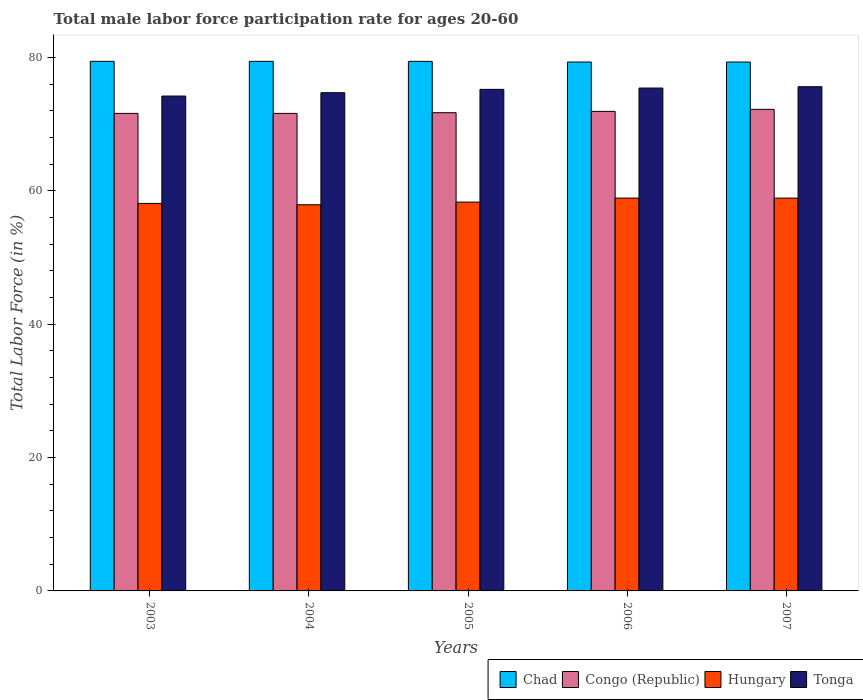How many different coloured bars are there?
Your answer should be very brief. 4. How many groups of bars are there?
Ensure brevity in your answer.  5. Are the number of bars per tick equal to the number of legend labels?
Provide a succinct answer. Yes. How many bars are there on the 4th tick from the left?
Offer a very short reply. 4. How many bars are there on the 3rd tick from the right?
Your answer should be very brief. 4. What is the label of the 5th group of bars from the left?
Offer a terse response. 2007. What is the male labor force participation rate in Hungary in 2004?
Your response must be concise. 57.9. Across all years, what is the maximum male labor force participation rate in Tonga?
Make the answer very short. 75.6. Across all years, what is the minimum male labor force participation rate in Tonga?
Offer a very short reply. 74.2. In which year was the male labor force participation rate in Congo (Republic) maximum?
Your answer should be compact. 2007. In which year was the male labor force participation rate in Chad minimum?
Your answer should be compact. 2006. What is the total male labor force participation rate in Congo (Republic) in the graph?
Offer a very short reply. 359. What is the difference between the male labor force participation rate in Congo (Republic) in 2003 and that in 2007?
Give a very brief answer. -0.6. What is the difference between the male labor force participation rate in Hungary in 2003 and the male labor force participation rate in Chad in 2004?
Your answer should be compact. -21.3. What is the average male labor force participation rate in Congo (Republic) per year?
Make the answer very short. 71.8. In the year 2004, what is the difference between the male labor force participation rate in Chad and male labor force participation rate in Tonga?
Your answer should be very brief. 4.7. What is the ratio of the male labor force participation rate in Tonga in 2005 to that in 2006?
Your response must be concise. 1. Is the difference between the male labor force participation rate in Chad in 2003 and 2004 greater than the difference between the male labor force participation rate in Tonga in 2003 and 2004?
Offer a very short reply. Yes. What is the difference between the highest and the second highest male labor force participation rate in Congo (Republic)?
Provide a succinct answer. 0.3. What is the difference between the highest and the lowest male labor force participation rate in Congo (Republic)?
Provide a succinct answer. 0.6. In how many years, is the male labor force participation rate in Tonga greater than the average male labor force participation rate in Tonga taken over all years?
Your answer should be very brief. 3. Is it the case that in every year, the sum of the male labor force participation rate in Tonga and male labor force participation rate in Congo (Republic) is greater than the sum of male labor force participation rate in Hungary and male labor force participation rate in Chad?
Provide a short and direct response. No. What does the 2nd bar from the left in 2004 represents?
Give a very brief answer. Congo (Republic). What does the 2nd bar from the right in 2003 represents?
Offer a terse response. Hungary. How many years are there in the graph?
Give a very brief answer. 5. How many legend labels are there?
Keep it short and to the point. 4. What is the title of the graph?
Your answer should be compact. Total male labor force participation rate for ages 20-60. What is the label or title of the X-axis?
Your response must be concise. Years. What is the label or title of the Y-axis?
Keep it short and to the point. Total Labor Force (in %). What is the Total Labor Force (in %) in Chad in 2003?
Keep it short and to the point. 79.4. What is the Total Labor Force (in %) in Congo (Republic) in 2003?
Offer a terse response. 71.6. What is the Total Labor Force (in %) of Hungary in 2003?
Keep it short and to the point. 58.1. What is the Total Labor Force (in %) of Tonga in 2003?
Provide a succinct answer. 74.2. What is the Total Labor Force (in %) in Chad in 2004?
Make the answer very short. 79.4. What is the Total Labor Force (in %) of Congo (Republic) in 2004?
Your answer should be very brief. 71.6. What is the Total Labor Force (in %) of Hungary in 2004?
Offer a very short reply. 57.9. What is the Total Labor Force (in %) of Tonga in 2004?
Provide a short and direct response. 74.7. What is the Total Labor Force (in %) of Chad in 2005?
Provide a succinct answer. 79.4. What is the Total Labor Force (in %) of Congo (Republic) in 2005?
Offer a very short reply. 71.7. What is the Total Labor Force (in %) in Hungary in 2005?
Provide a short and direct response. 58.3. What is the Total Labor Force (in %) of Tonga in 2005?
Offer a terse response. 75.2. What is the Total Labor Force (in %) in Chad in 2006?
Make the answer very short. 79.3. What is the Total Labor Force (in %) in Congo (Republic) in 2006?
Offer a very short reply. 71.9. What is the Total Labor Force (in %) of Hungary in 2006?
Provide a succinct answer. 58.9. What is the Total Labor Force (in %) of Tonga in 2006?
Your response must be concise. 75.4. What is the Total Labor Force (in %) of Chad in 2007?
Provide a succinct answer. 79.3. What is the Total Labor Force (in %) in Congo (Republic) in 2007?
Keep it short and to the point. 72.2. What is the Total Labor Force (in %) of Hungary in 2007?
Make the answer very short. 58.9. What is the Total Labor Force (in %) in Tonga in 2007?
Provide a succinct answer. 75.6. Across all years, what is the maximum Total Labor Force (in %) in Chad?
Your answer should be compact. 79.4. Across all years, what is the maximum Total Labor Force (in %) in Congo (Republic)?
Your response must be concise. 72.2. Across all years, what is the maximum Total Labor Force (in %) in Hungary?
Offer a very short reply. 58.9. Across all years, what is the maximum Total Labor Force (in %) of Tonga?
Your response must be concise. 75.6. Across all years, what is the minimum Total Labor Force (in %) of Chad?
Provide a succinct answer. 79.3. Across all years, what is the minimum Total Labor Force (in %) of Congo (Republic)?
Your answer should be very brief. 71.6. Across all years, what is the minimum Total Labor Force (in %) of Hungary?
Your response must be concise. 57.9. Across all years, what is the minimum Total Labor Force (in %) of Tonga?
Your response must be concise. 74.2. What is the total Total Labor Force (in %) of Chad in the graph?
Offer a terse response. 396.8. What is the total Total Labor Force (in %) in Congo (Republic) in the graph?
Provide a short and direct response. 359. What is the total Total Labor Force (in %) of Hungary in the graph?
Provide a succinct answer. 292.1. What is the total Total Labor Force (in %) of Tonga in the graph?
Keep it short and to the point. 375.1. What is the difference between the Total Labor Force (in %) of Chad in 2003 and that in 2004?
Your answer should be very brief. 0. What is the difference between the Total Labor Force (in %) in Hungary in 2003 and that in 2006?
Provide a succinct answer. -0.8. What is the difference between the Total Labor Force (in %) in Tonga in 2003 and that in 2007?
Keep it short and to the point. -1.4. What is the difference between the Total Labor Force (in %) of Congo (Republic) in 2004 and that in 2005?
Provide a short and direct response. -0.1. What is the difference between the Total Labor Force (in %) in Hungary in 2004 and that in 2005?
Ensure brevity in your answer.  -0.4. What is the difference between the Total Labor Force (in %) of Tonga in 2004 and that in 2005?
Keep it short and to the point. -0.5. What is the difference between the Total Labor Force (in %) of Congo (Republic) in 2004 and that in 2006?
Provide a succinct answer. -0.3. What is the difference between the Total Labor Force (in %) of Tonga in 2004 and that in 2006?
Your answer should be compact. -0.7. What is the difference between the Total Labor Force (in %) of Chad in 2004 and that in 2007?
Provide a short and direct response. 0.1. What is the difference between the Total Labor Force (in %) in Hungary in 2004 and that in 2007?
Offer a terse response. -1. What is the difference between the Total Labor Force (in %) in Congo (Republic) in 2005 and that in 2006?
Your answer should be compact. -0.2. What is the difference between the Total Labor Force (in %) of Tonga in 2005 and that in 2006?
Provide a succinct answer. -0.2. What is the difference between the Total Labor Force (in %) of Chad in 2005 and that in 2007?
Offer a very short reply. 0.1. What is the difference between the Total Labor Force (in %) of Congo (Republic) in 2005 and that in 2007?
Keep it short and to the point. -0.5. What is the difference between the Total Labor Force (in %) of Hungary in 2006 and that in 2007?
Offer a very short reply. 0. What is the difference between the Total Labor Force (in %) of Chad in 2003 and the Total Labor Force (in %) of Congo (Republic) in 2004?
Ensure brevity in your answer.  7.8. What is the difference between the Total Labor Force (in %) of Congo (Republic) in 2003 and the Total Labor Force (in %) of Tonga in 2004?
Your answer should be compact. -3.1. What is the difference between the Total Labor Force (in %) in Hungary in 2003 and the Total Labor Force (in %) in Tonga in 2004?
Keep it short and to the point. -16.6. What is the difference between the Total Labor Force (in %) of Chad in 2003 and the Total Labor Force (in %) of Congo (Republic) in 2005?
Offer a very short reply. 7.7. What is the difference between the Total Labor Force (in %) in Chad in 2003 and the Total Labor Force (in %) in Hungary in 2005?
Make the answer very short. 21.1. What is the difference between the Total Labor Force (in %) of Chad in 2003 and the Total Labor Force (in %) of Tonga in 2005?
Your answer should be very brief. 4.2. What is the difference between the Total Labor Force (in %) of Congo (Republic) in 2003 and the Total Labor Force (in %) of Hungary in 2005?
Keep it short and to the point. 13.3. What is the difference between the Total Labor Force (in %) of Hungary in 2003 and the Total Labor Force (in %) of Tonga in 2005?
Offer a very short reply. -17.1. What is the difference between the Total Labor Force (in %) in Chad in 2003 and the Total Labor Force (in %) in Congo (Republic) in 2006?
Give a very brief answer. 7.5. What is the difference between the Total Labor Force (in %) of Chad in 2003 and the Total Labor Force (in %) of Tonga in 2006?
Keep it short and to the point. 4. What is the difference between the Total Labor Force (in %) in Congo (Republic) in 2003 and the Total Labor Force (in %) in Tonga in 2006?
Offer a terse response. -3.8. What is the difference between the Total Labor Force (in %) in Hungary in 2003 and the Total Labor Force (in %) in Tonga in 2006?
Your answer should be compact. -17.3. What is the difference between the Total Labor Force (in %) in Chad in 2003 and the Total Labor Force (in %) in Congo (Republic) in 2007?
Give a very brief answer. 7.2. What is the difference between the Total Labor Force (in %) in Hungary in 2003 and the Total Labor Force (in %) in Tonga in 2007?
Your answer should be compact. -17.5. What is the difference between the Total Labor Force (in %) in Chad in 2004 and the Total Labor Force (in %) in Hungary in 2005?
Your response must be concise. 21.1. What is the difference between the Total Labor Force (in %) of Congo (Republic) in 2004 and the Total Labor Force (in %) of Hungary in 2005?
Provide a succinct answer. 13.3. What is the difference between the Total Labor Force (in %) in Hungary in 2004 and the Total Labor Force (in %) in Tonga in 2005?
Keep it short and to the point. -17.3. What is the difference between the Total Labor Force (in %) in Chad in 2004 and the Total Labor Force (in %) in Congo (Republic) in 2006?
Give a very brief answer. 7.5. What is the difference between the Total Labor Force (in %) of Chad in 2004 and the Total Labor Force (in %) of Hungary in 2006?
Provide a succinct answer. 20.5. What is the difference between the Total Labor Force (in %) in Congo (Republic) in 2004 and the Total Labor Force (in %) in Hungary in 2006?
Offer a very short reply. 12.7. What is the difference between the Total Labor Force (in %) in Hungary in 2004 and the Total Labor Force (in %) in Tonga in 2006?
Offer a very short reply. -17.5. What is the difference between the Total Labor Force (in %) in Congo (Republic) in 2004 and the Total Labor Force (in %) in Hungary in 2007?
Your answer should be very brief. 12.7. What is the difference between the Total Labor Force (in %) of Congo (Republic) in 2004 and the Total Labor Force (in %) of Tonga in 2007?
Your response must be concise. -4. What is the difference between the Total Labor Force (in %) of Hungary in 2004 and the Total Labor Force (in %) of Tonga in 2007?
Provide a short and direct response. -17.7. What is the difference between the Total Labor Force (in %) of Chad in 2005 and the Total Labor Force (in %) of Congo (Republic) in 2006?
Make the answer very short. 7.5. What is the difference between the Total Labor Force (in %) in Chad in 2005 and the Total Labor Force (in %) in Hungary in 2006?
Ensure brevity in your answer.  20.5. What is the difference between the Total Labor Force (in %) in Congo (Republic) in 2005 and the Total Labor Force (in %) in Hungary in 2006?
Offer a terse response. 12.8. What is the difference between the Total Labor Force (in %) of Congo (Republic) in 2005 and the Total Labor Force (in %) of Tonga in 2006?
Keep it short and to the point. -3.7. What is the difference between the Total Labor Force (in %) of Hungary in 2005 and the Total Labor Force (in %) of Tonga in 2006?
Make the answer very short. -17.1. What is the difference between the Total Labor Force (in %) of Chad in 2005 and the Total Labor Force (in %) of Congo (Republic) in 2007?
Give a very brief answer. 7.2. What is the difference between the Total Labor Force (in %) of Chad in 2005 and the Total Labor Force (in %) of Hungary in 2007?
Provide a short and direct response. 20.5. What is the difference between the Total Labor Force (in %) of Chad in 2005 and the Total Labor Force (in %) of Tonga in 2007?
Give a very brief answer. 3.8. What is the difference between the Total Labor Force (in %) in Hungary in 2005 and the Total Labor Force (in %) in Tonga in 2007?
Offer a very short reply. -17.3. What is the difference between the Total Labor Force (in %) in Chad in 2006 and the Total Labor Force (in %) in Congo (Republic) in 2007?
Your answer should be compact. 7.1. What is the difference between the Total Labor Force (in %) of Chad in 2006 and the Total Labor Force (in %) of Hungary in 2007?
Keep it short and to the point. 20.4. What is the difference between the Total Labor Force (in %) in Chad in 2006 and the Total Labor Force (in %) in Tonga in 2007?
Give a very brief answer. 3.7. What is the difference between the Total Labor Force (in %) in Congo (Republic) in 2006 and the Total Labor Force (in %) in Hungary in 2007?
Keep it short and to the point. 13. What is the difference between the Total Labor Force (in %) of Hungary in 2006 and the Total Labor Force (in %) of Tonga in 2007?
Your answer should be very brief. -16.7. What is the average Total Labor Force (in %) of Chad per year?
Keep it short and to the point. 79.36. What is the average Total Labor Force (in %) in Congo (Republic) per year?
Offer a very short reply. 71.8. What is the average Total Labor Force (in %) of Hungary per year?
Your answer should be very brief. 58.42. What is the average Total Labor Force (in %) in Tonga per year?
Offer a terse response. 75.02. In the year 2003, what is the difference between the Total Labor Force (in %) of Chad and Total Labor Force (in %) of Hungary?
Offer a terse response. 21.3. In the year 2003, what is the difference between the Total Labor Force (in %) of Congo (Republic) and Total Labor Force (in %) of Hungary?
Ensure brevity in your answer.  13.5. In the year 2003, what is the difference between the Total Labor Force (in %) in Hungary and Total Labor Force (in %) in Tonga?
Your answer should be compact. -16.1. In the year 2004, what is the difference between the Total Labor Force (in %) of Chad and Total Labor Force (in %) of Congo (Republic)?
Offer a very short reply. 7.8. In the year 2004, what is the difference between the Total Labor Force (in %) in Chad and Total Labor Force (in %) in Hungary?
Your answer should be compact. 21.5. In the year 2004, what is the difference between the Total Labor Force (in %) of Congo (Republic) and Total Labor Force (in %) of Hungary?
Ensure brevity in your answer.  13.7. In the year 2004, what is the difference between the Total Labor Force (in %) of Hungary and Total Labor Force (in %) of Tonga?
Your answer should be very brief. -16.8. In the year 2005, what is the difference between the Total Labor Force (in %) in Chad and Total Labor Force (in %) in Hungary?
Your answer should be compact. 21.1. In the year 2005, what is the difference between the Total Labor Force (in %) of Chad and Total Labor Force (in %) of Tonga?
Ensure brevity in your answer.  4.2. In the year 2005, what is the difference between the Total Labor Force (in %) in Congo (Republic) and Total Labor Force (in %) in Tonga?
Offer a terse response. -3.5. In the year 2005, what is the difference between the Total Labor Force (in %) in Hungary and Total Labor Force (in %) in Tonga?
Your answer should be very brief. -16.9. In the year 2006, what is the difference between the Total Labor Force (in %) of Chad and Total Labor Force (in %) of Hungary?
Keep it short and to the point. 20.4. In the year 2006, what is the difference between the Total Labor Force (in %) in Chad and Total Labor Force (in %) in Tonga?
Provide a succinct answer. 3.9. In the year 2006, what is the difference between the Total Labor Force (in %) in Hungary and Total Labor Force (in %) in Tonga?
Ensure brevity in your answer.  -16.5. In the year 2007, what is the difference between the Total Labor Force (in %) in Chad and Total Labor Force (in %) in Congo (Republic)?
Provide a succinct answer. 7.1. In the year 2007, what is the difference between the Total Labor Force (in %) in Chad and Total Labor Force (in %) in Hungary?
Give a very brief answer. 20.4. In the year 2007, what is the difference between the Total Labor Force (in %) in Hungary and Total Labor Force (in %) in Tonga?
Provide a short and direct response. -16.7. What is the ratio of the Total Labor Force (in %) in Chad in 2003 to that in 2004?
Offer a very short reply. 1. What is the ratio of the Total Labor Force (in %) of Congo (Republic) in 2003 to that in 2004?
Offer a terse response. 1. What is the ratio of the Total Labor Force (in %) of Chad in 2003 to that in 2005?
Your answer should be very brief. 1. What is the ratio of the Total Labor Force (in %) of Hungary in 2003 to that in 2005?
Keep it short and to the point. 1. What is the ratio of the Total Labor Force (in %) in Tonga in 2003 to that in 2005?
Offer a terse response. 0.99. What is the ratio of the Total Labor Force (in %) in Hungary in 2003 to that in 2006?
Give a very brief answer. 0.99. What is the ratio of the Total Labor Force (in %) of Tonga in 2003 to that in 2006?
Your answer should be compact. 0.98. What is the ratio of the Total Labor Force (in %) in Chad in 2003 to that in 2007?
Your response must be concise. 1. What is the ratio of the Total Labor Force (in %) of Hungary in 2003 to that in 2007?
Provide a succinct answer. 0.99. What is the ratio of the Total Labor Force (in %) of Tonga in 2003 to that in 2007?
Your answer should be compact. 0.98. What is the ratio of the Total Labor Force (in %) of Chad in 2004 to that in 2005?
Offer a very short reply. 1. What is the ratio of the Total Labor Force (in %) in Congo (Republic) in 2004 to that in 2005?
Your answer should be compact. 1. What is the ratio of the Total Labor Force (in %) of Hungary in 2004 to that in 2006?
Offer a very short reply. 0.98. What is the ratio of the Total Labor Force (in %) of Tonga in 2004 to that in 2007?
Provide a short and direct response. 0.99. What is the ratio of the Total Labor Force (in %) in Hungary in 2005 to that in 2006?
Provide a succinct answer. 0.99. What is the ratio of the Total Labor Force (in %) of Tonga in 2005 to that in 2006?
Keep it short and to the point. 1. What is the ratio of the Total Labor Force (in %) of Tonga in 2005 to that in 2007?
Provide a succinct answer. 0.99. What is the ratio of the Total Labor Force (in %) in Chad in 2006 to that in 2007?
Offer a very short reply. 1. What is the ratio of the Total Labor Force (in %) of Congo (Republic) in 2006 to that in 2007?
Offer a terse response. 1. What is the ratio of the Total Labor Force (in %) in Hungary in 2006 to that in 2007?
Keep it short and to the point. 1. What is the difference between the highest and the second highest Total Labor Force (in %) in Congo (Republic)?
Your answer should be compact. 0.3. What is the difference between the highest and the second highest Total Labor Force (in %) in Hungary?
Offer a terse response. 0. What is the difference between the highest and the second highest Total Labor Force (in %) in Tonga?
Ensure brevity in your answer.  0.2. What is the difference between the highest and the lowest Total Labor Force (in %) in Hungary?
Offer a terse response. 1. What is the difference between the highest and the lowest Total Labor Force (in %) in Tonga?
Provide a short and direct response. 1.4. 